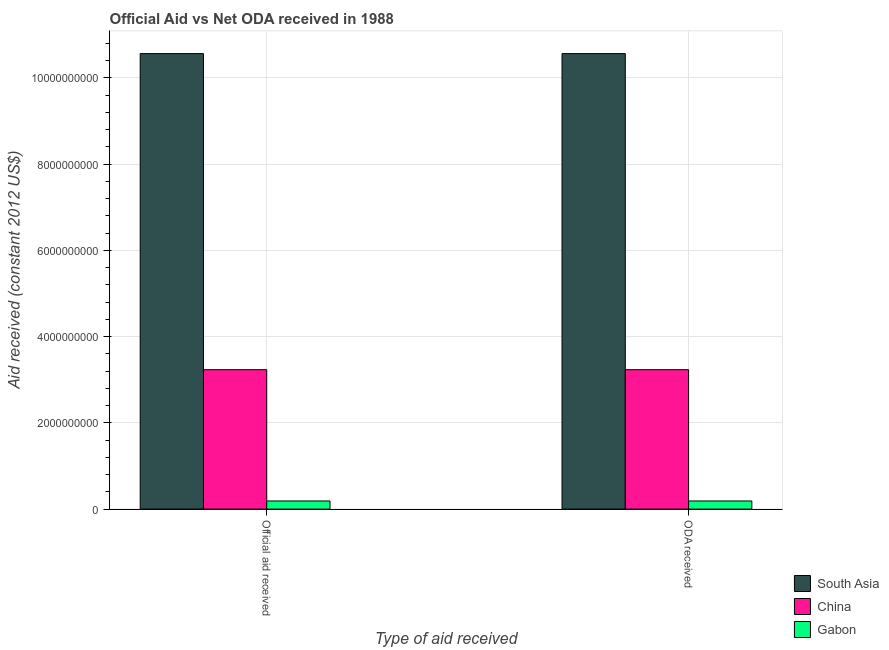Are the number of bars on each tick of the X-axis equal?
Your response must be concise. Yes. How many bars are there on the 2nd tick from the right?
Offer a terse response. 3. What is the label of the 1st group of bars from the left?
Your answer should be very brief. Official aid received. What is the official aid received in China?
Provide a succinct answer. 3.23e+09. Across all countries, what is the maximum official aid received?
Provide a succinct answer. 1.06e+1. Across all countries, what is the minimum oda received?
Ensure brevity in your answer.  1.88e+08. In which country was the oda received maximum?
Your answer should be compact. South Asia. In which country was the official aid received minimum?
Provide a short and direct response. Gabon. What is the total oda received in the graph?
Provide a short and direct response. 1.40e+1. What is the difference between the oda received in Gabon and that in South Asia?
Make the answer very short. -1.04e+1. What is the difference between the oda received in South Asia and the official aid received in China?
Offer a very short reply. 7.33e+09. What is the average oda received per country?
Offer a very short reply. 4.66e+09. In how many countries, is the official aid received greater than 3600000000 US$?
Offer a very short reply. 1. What is the ratio of the oda received in Gabon to that in China?
Your response must be concise. 0.06. In how many countries, is the oda received greater than the average oda received taken over all countries?
Keep it short and to the point. 1. What does the 2nd bar from the left in ODA received represents?
Your answer should be very brief. China. How many bars are there?
Your response must be concise. 6. How many countries are there in the graph?
Offer a very short reply. 3. How are the legend labels stacked?
Your answer should be very brief. Vertical. What is the title of the graph?
Provide a succinct answer. Official Aid vs Net ODA received in 1988 . What is the label or title of the X-axis?
Provide a succinct answer. Type of aid received. What is the label or title of the Y-axis?
Your answer should be compact. Aid received (constant 2012 US$). What is the Aid received (constant 2012 US$) in South Asia in Official aid received?
Provide a short and direct response. 1.06e+1. What is the Aid received (constant 2012 US$) in China in Official aid received?
Your answer should be very brief. 3.23e+09. What is the Aid received (constant 2012 US$) in Gabon in Official aid received?
Provide a succinct answer. 1.88e+08. What is the Aid received (constant 2012 US$) in South Asia in ODA received?
Give a very brief answer. 1.06e+1. What is the Aid received (constant 2012 US$) of China in ODA received?
Offer a very short reply. 3.23e+09. What is the Aid received (constant 2012 US$) in Gabon in ODA received?
Provide a succinct answer. 1.88e+08. Across all Type of aid received, what is the maximum Aid received (constant 2012 US$) of South Asia?
Ensure brevity in your answer.  1.06e+1. Across all Type of aid received, what is the maximum Aid received (constant 2012 US$) of China?
Keep it short and to the point. 3.23e+09. Across all Type of aid received, what is the maximum Aid received (constant 2012 US$) in Gabon?
Provide a succinct answer. 1.88e+08. Across all Type of aid received, what is the minimum Aid received (constant 2012 US$) of South Asia?
Your answer should be compact. 1.06e+1. Across all Type of aid received, what is the minimum Aid received (constant 2012 US$) of China?
Your answer should be compact. 3.23e+09. Across all Type of aid received, what is the minimum Aid received (constant 2012 US$) in Gabon?
Your response must be concise. 1.88e+08. What is the total Aid received (constant 2012 US$) in South Asia in the graph?
Your answer should be compact. 2.11e+1. What is the total Aid received (constant 2012 US$) in China in the graph?
Make the answer very short. 6.47e+09. What is the total Aid received (constant 2012 US$) in Gabon in the graph?
Provide a succinct answer. 3.77e+08. What is the difference between the Aid received (constant 2012 US$) of China in Official aid received and that in ODA received?
Keep it short and to the point. 0. What is the difference between the Aid received (constant 2012 US$) in Gabon in Official aid received and that in ODA received?
Your answer should be very brief. 0. What is the difference between the Aid received (constant 2012 US$) in South Asia in Official aid received and the Aid received (constant 2012 US$) in China in ODA received?
Ensure brevity in your answer.  7.33e+09. What is the difference between the Aid received (constant 2012 US$) in South Asia in Official aid received and the Aid received (constant 2012 US$) in Gabon in ODA received?
Your response must be concise. 1.04e+1. What is the difference between the Aid received (constant 2012 US$) of China in Official aid received and the Aid received (constant 2012 US$) of Gabon in ODA received?
Ensure brevity in your answer.  3.05e+09. What is the average Aid received (constant 2012 US$) of South Asia per Type of aid received?
Your answer should be very brief. 1.06e+1. What is the average Aid received (constant 2012 US$) of China per Type of aid received?
Keep it short and to the point. 3.23e+09. What is the average Aid received (constant 2012 US$) in Gabon per Type of aid received?
Your response must be concise. 1.88e+08. What is the difference between the Aid received (constant 2012 US$) in South Asia and Aid received (constant 2012 US$) in China in Official aid received?
Keep it short and to the point. 7.33e+09. What is the difference between the Aid received (constant 2012 US$) in South Asia and Aid received (constant 2012 US$) in Gabon in Official aid received?
Keep it short and to the point. 1.04e+1. What is the difference between the Aid received (constant 2012 US$) of China and Aid received (constant 2012 US$) of Gabon in Official aid received?
Ensure brevity in your answer.  3.05e+09. What is the difference between the Aid received (constant 2012 US$) in South Asia and Aid received (constant 2012 US$) in China in ODA received?
Offer a terse response. 7.33e+09. What is the difference between the Aid received (constant 2012 US$) of South Asia and Aid received (constant 2012 US$) of Gabon in ODA received?
Offer a very short reply. 1.04e+1. What is the difference between the Aid received (constant 2012 US$) in China and Aid received (constant 2012 US$) in Gabon in ODA received?
Give a very brief answer. 3.05e+09. What is the ratio of the Aid received (constant 2012 US$) in South Asia in Official aid received to that in ODA received?
Keep it short and to the point. 1. What is the ratio of the Aid received (constant 2012 US$) in Gabon in Official aid received to that in ODA received?
Provide a succinct answer. 1. What is the difference between the highest and the second highest Aid received (constant 2012 US$) of Gabon?
Offer a very short reply. 0. What is the difference between the highest and the lowest Aid received (constant 2012 US$) of South Asia?
Give a very brief answer. 0. What is the difference between the highest and the lowest Aid received (constant 2012 US$) in China?
Keep it short and to the point. 0. What is the difference between the highest and the lowest Aid received (constant 2012 US$) of Gabon?
Your response must be concise. 0. 